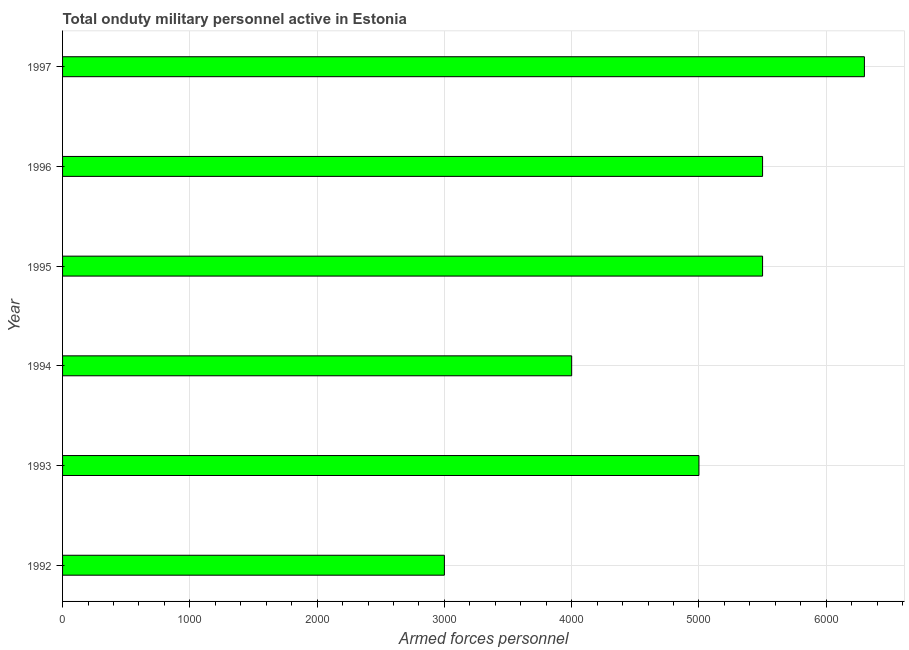Does the graph contain any zero values?
Offer a terse response. No. What is the title of the graph?
Give a very brief answer. Total onduty military personnel active in Estonia. What is the label or title of the X-axis?
Provide a succinct answer. Armed forces personnel. What is the number of armed forces personnel in 1994?
Your answer should be very brief. 4000. Across all years, what is the maximum number of armed forces personnel?
Your response must be concise. 6300. Across all years, what is the minimum number of armed forces personnel?
Make the answer very short. 3000. In which year was the number of armed forces personnel maximum?
Your answer should be very brief. 1997. In which year was the number of armed forces personnel minimum?
Provide a short and direct response. 1992. What is the sum of the number of armed forces personnel?
Your answer should be very brief. 2.93e+04. What is the difference between the number of armed forces personnel in 1992 and 1993?
Give a very brief answer. -2000. What is the average number of armed forces personnel per year?
Your answer should be compact. 4883. What is the median number of armed forces personnel?
Make the answer very short. 5250. What is the ratio of the number of armed forces personnel in 1996 to that in 1997?
Offer a very short reply. 0.87. What is the difference between the highest and the second highest number of armed forces personnel?
Keep it short and to the point. 800. Is the sum of the number of armed forces personnel in 1992 and 1997 greater than the maximum number of armed forces personnel across all years?
Give a very brief answer. Yes. What is the difference between the highest and the lowest number of armed forces personnel?
Give a very brief answer. 3300. How many bars are there?
Provide a short and direct response. 6. Are all the bars in the graph horizontal?
Give a very brief answer. Yes. How many years are there in the graph?
Keep it short and to the point. 6. What is the difference between two consecutive major ticks on the X-axis?
Keep it short and to the point. 1000. Are the values on the major ticks of X-axis written in scientific E-notation?
Keep it short and to the point. No. What is the Armed forces personnel in 1992?
Provide a succinct answer. 3000. What is the Armed forces personnel in 1993?
Your response must be concise. 5000. What is the Armed forces personnel in 1994?
Your answer should be compact. 4000. What is the Armed forces personnel in 1995?
Offer a terse response. 5500. What is the Armed forces personnel of 1996?
Offer a terse response. 5500. What is the Armed forces personnel in 1997?
Your answer should be very brief. 6300. What is the difference between the Armed forces personnel in 1992 and 1993?
Provide a short and direct response. -2000. What is the difference between the Armed forces personnel in 1992 and 1994?
Offer a terse response. -1000. What is the difference between the Armed forces personnel in 1992 and 1995?
Offer a terse response. -2500. What is the difference between the Armed forces personnel in 1992 and 1996?
Offer a very short reply. -2500. What is the difference between the Armed forces personnel in 1992 and 1997?
Your answer should be very brief. -3300. What is the difference between the Armed forces personnel in 1993 and 1994?
Offer a very short reply. 1000. What is the difference between the Armed forces personnel in 1993 and 1995?
Keep it short and to the point. -500. What is the difference between the Armed forces personnel in 1993 and 1996?
Your answer should be compact. -500. What is the difference between the Armed forces personnel in 1993 and 1997?
Provide a succinct answer. -1300. What is the difference between the Armed forces personnel in 1994 and 1995?
Make the answer very short. -1500. What is the difference between the Armed forces personnel in 1994 and 1996?
Your answer should be compact. -1500. What is the difference between the Armed forces personnel in 1994 and 1997?
Offer a terse response. -2300. What is the difference between the Armed forces personnel in 1995 and 1997?
Give a very brief answer. -800. What is the difference between the Armed forces personnel in 1996 and 1997?
Keep it short and to the point. -800. What is the ratio of the Armed forces personnel in 1992 to that in 1993?
Provide a short and direct response. 0.6. What is the ratio of the Armed forces personnel in 1992 to that in 1995?
Make the answer very short. 0.55. What is the ratio of the Armed forces personnel in 1992 to that in 1996?
Provide a succinct answer. 0.55. What is the ratio of the Armed forces personnel in 1992 to that in 1997?
Provide a succinct answer. 0.48. What is the ratio of the Armed forces personnel in 1993 to that in 1994?
Keep it short and to the point. 1.25. What is the ratio of the Armed forces personnel in 1993 to that in 1995?
Ensure brevity in your answer.  0.91. What is the ratio of the Armed forces personnel in 1993 to that in 1996?
Keep it short and to the point. 0.91. What is the ratio of the Armed forces personnel in 1993 to that in 1997?
Your response must be concise. 0.79. What is the ratio of the Armed forces personnel in 1994 to that in 1995?
Give a very brief answer. 0.73. What is the ratio of the Armed forces personnel in 1994 to that in 1996?
Your answer should be compact. 0.73. What is the ratio of the Armed forces personnel in 1994 to that in 1997?
Offer a terse response. 0.64. What is the ratio of the Armed forces personnel in 1995 to that in 1997?
Offer a very short reply. 0.87. What is the ratio of the Armed forces personnel in 1996 to that in 1997?
Your answer should be very brief. 0.87. 